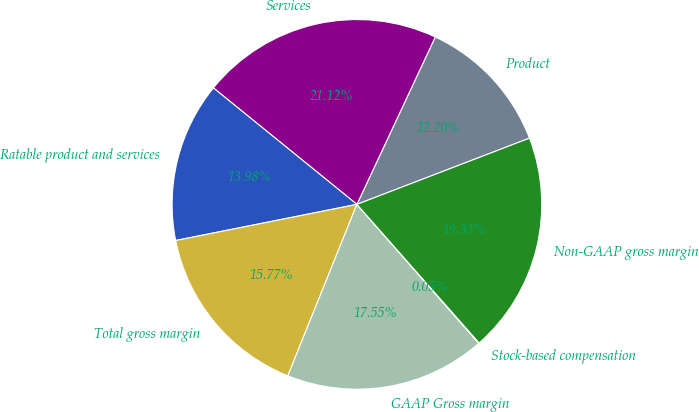<chart> <loc_0><loc_0><loc_500><loc_500><pie_chart><fcel>Product<fcel>Services<fcel>Ratable product and services<fcel>Total gross margin<fcel>GAAP Gross margin<fcel>Stock-based compensation<fcel>Non-GAAP gross margin<nl><fcel>12.2%<fcel>21.12%<fcel>13.98%<fcel>15.77%<fcel>17.55%<fcel>0.05%<fcel>19.33%<nl></chart> 